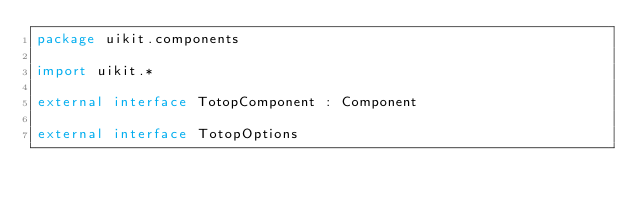Convert code to text. <code><loc_0><loc_0><loc_500><loc_500><_Kotlin_>package uikit.components

import uikit.*

external interface TotopComponent : Component

external interface TotopOptions
</code> 